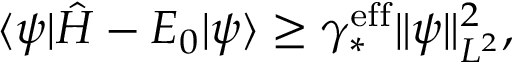Convert formula to latex. <formula><loc_0><loc_0><loc_500><loc_500>\langle \psi | \hat { H } - E _ { 0 } | \psi \rangle \geq \gamma _ { * } ^ { e f f } \| \psi \| _ { L ^ { 2 } } ^ { 2 } ,</formula> 